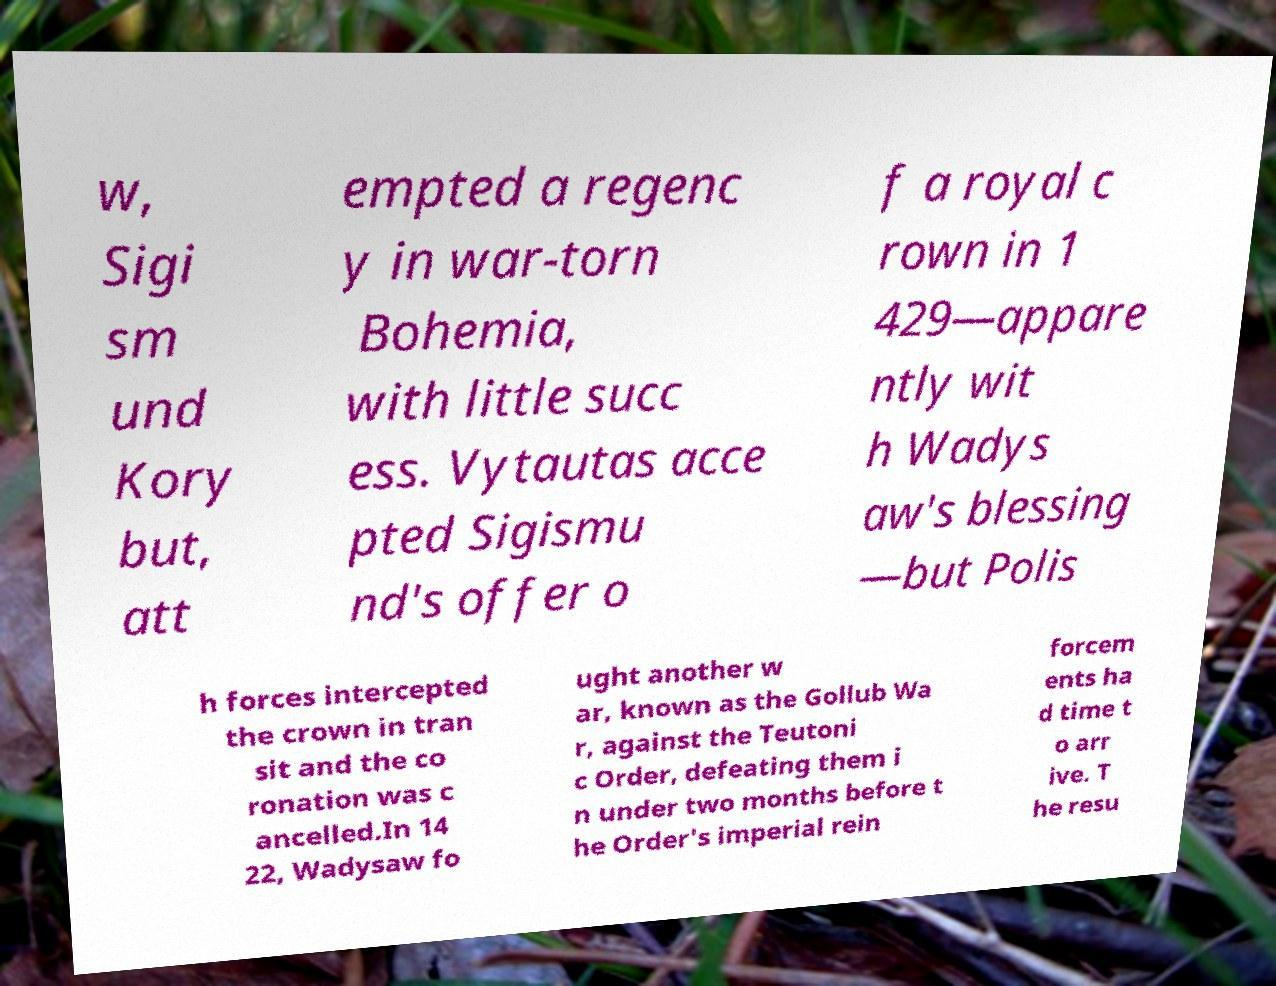Could you assist in decoding the text presented in this image and type it out clearly? w, Sigi sm und Kory but, att empted a regenc y in war-torn Bohemia, with little succ ess. Vytautas acce pted Sigismu nd's offer o f a royal c rown in 1 429—appare ntly wit h Wadys aw's blessing —but Polis h forces intercepted the crown in tran sit and the co ronation was c ancelled.In 14 22, Wadysaw fo ught another w ar, known as the Gollub Wa r, against the Teutoni c Order, defeating them i n under two months before t he Order's imperial rein forcem ents ha d time t o arr ive. T he resu 